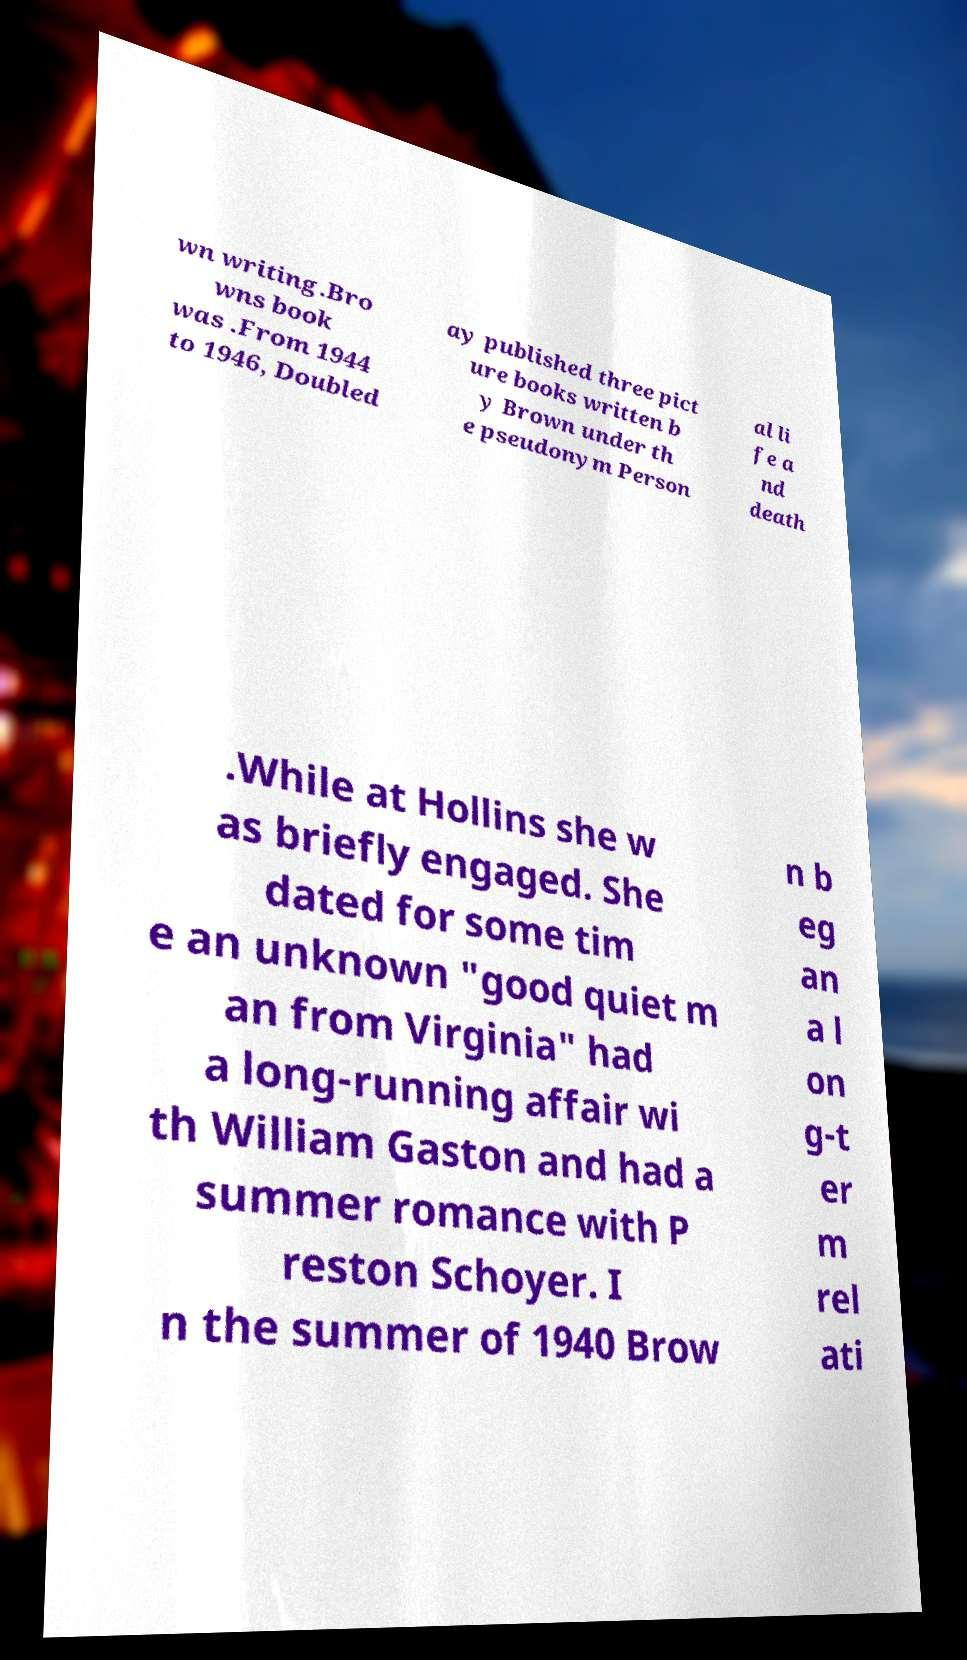Could you assist in decoding the text presented in this image and type it out clearly? wn writing.Bro wns book was .From 1944 to 1946, Doubled ay published three pict ure books written b y Brown under th e pseudonym Person al li fe a nd death .While at Hollins she w as briefly engaged. She dated for some tim e an unknown "good quiet m an from Virginia" had a long-running affair wi th William Gaston and had a summer romance with P reston Schoyer. I n the summer of 1940 Brow n b eg an a l on g-t er m rel ati 